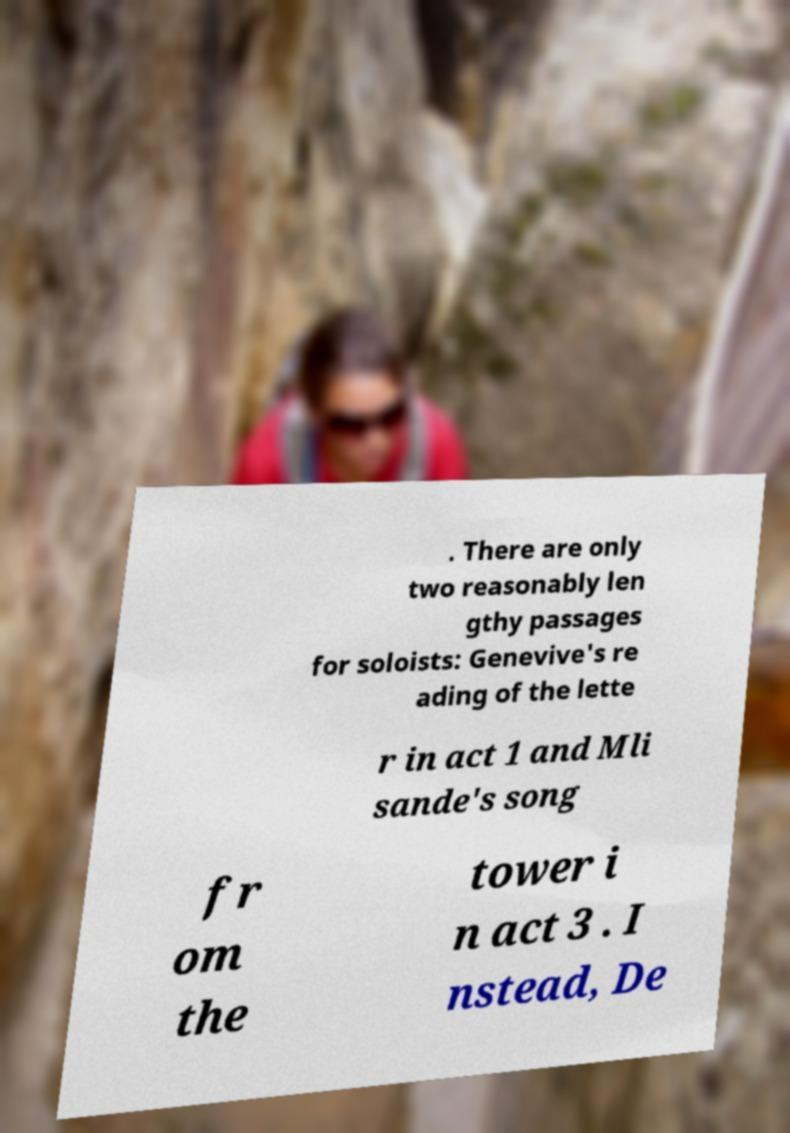Please identify and transcribe the text found in this image. . There are only two reasonably len gthy passages for soloists: Genevive's re ading of the lette r in act 1 and Mli sande's song fr om the tower i n act 3 . I nstead, De 